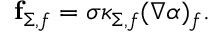<formula> <loc_0><loc_0><loc_500><loc_500>\begin{array} { r } { f _ { \Sigma , f } = \sigma \kappa _ { \Sigma , f } ( \nabla \alpha ) _ { f } . } \end{array}</formula> 